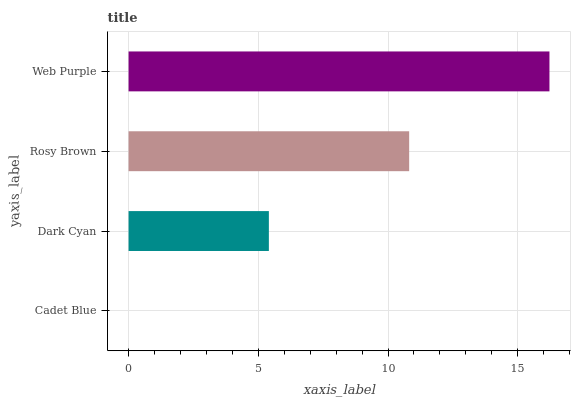Is Cadet Blue the minimum?
Answer yes or no. Yes. Is Web Purple the maximum?
Answer yes or no. Yes. Is Dark Cyan the minimum?
Answer yes or no. No. Is Dark Cyan the maximum?
Answer yes or no. No. Is Dark Cyan greater than Cadet Blue?
Answer yes or no. Yes. Is Cadet Blue less than Dark Cyan?
Answer yes or no. Yes. Is Cadet Blue greater than Dark Cyan?
Answer yes or no. No. Is Dark Cyan less than Cadet Blue?
Answer yes or no. No. Is Rosy Brown the high median?
Answer yes or no. Yes. Is Dark Cyan the low median?
Answer yes or no. Yes. Is Dark Cyan the high median?
Answer yes or no. No. Is Rosy Brown the low median?
Answer yes or no. No. 